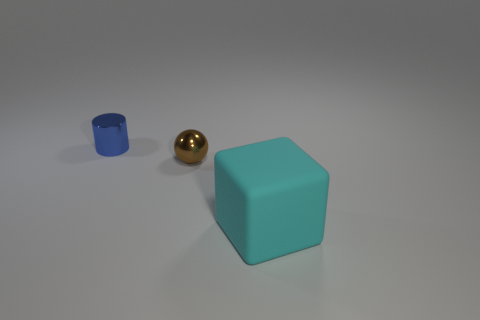Do these objects convey any particular theme or concept? The arrangement of a sphere, cylinder, and cube might be interpreted as a study of geometric shapes, each with a distinct color, highlighting forms and how they interact with light. It evokes a sense of simplicity and balance, perhaps alluding to basic elements of design and composition. 